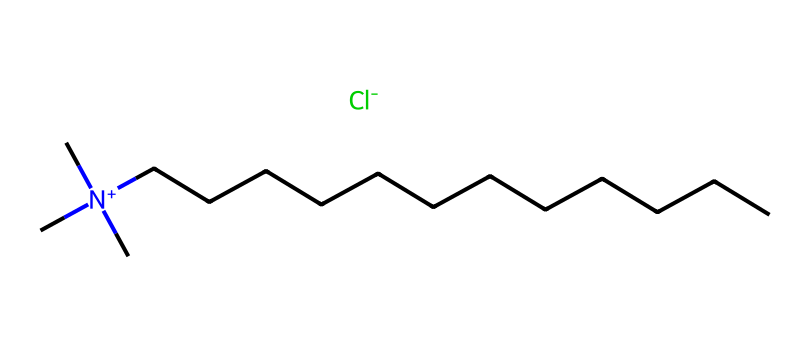What is the molecular formula of this chemical? The chemical's SMILES representation indicates it has one nitrogen atom (from [N+]) and is associated with a larger carbon (C) chain and a chloride ion (Cl-), allowing us to derive its molecular formula. The presence of the nitrogen suggests it is a quaternary ammonium compound, and the overall connection of atoms confirms it to be C21H38ClN.
Answer: C21H38ClN How many carbon atoms are in benzalkonium chloride? By examining the SMILES representation, we count the long carbon chain, which has 13 carbon atoms, and add the three from the three methyl groups attached to the nitrogen, totaling 16 carbon atoms.
Answer: 16 What type of ion is present in the molecular structure? The SMILES representation shows [Cl-], indicating the presence of a chloride ion. The presence of an anion balances the positive charge of the quaternary ammonium.
Answer: chloride How many hydrogen atoms are likely attached to the nitrogen in this compound? The nitrogen is positively charged ([N+]), suggesting it has no hydrogen atoms attached to it in this quaternary structure; instead, it is bonded to three alkyl groups (the carbon chains).
Answer: 0 What functional group is implied by the nitrogen's structure in benzalkonium chloride? The nitrogen's structure being positively charged and bonded to four substituents indicates that it belongs to the functional group known as quaternary ammonium.
Answer: quaternary ammonium What is the general use of benzalkonium chloride in medical products? Benzalkonium chloride is commonly used as a preservative in ophthalmic solutions due to its antimicrobial properties, helping prevent contamination in eye drops.
Answer: preservative 